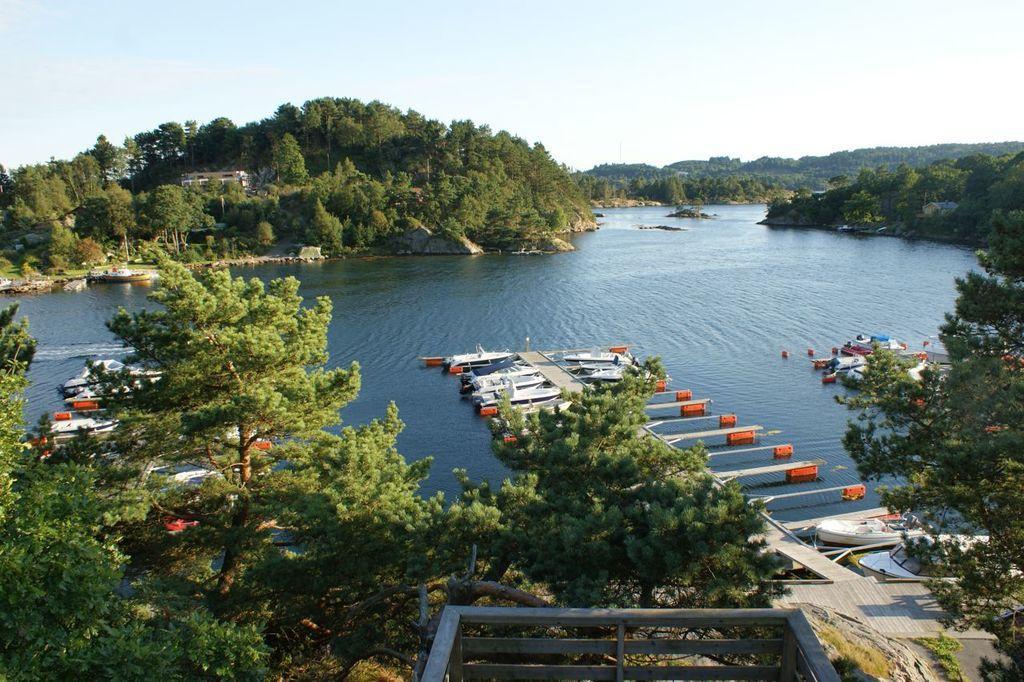Please provide a concise description of this image. It is a shipyard there are a lot of ships kept beside a bridge on the water and around the shipyard there is a lot of greenery with plenty of trees and in the background there is a sky. 